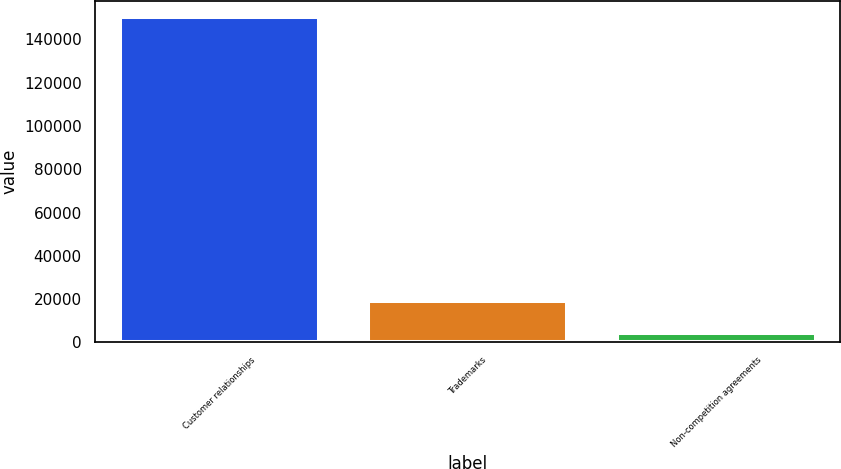<chart> <loc_0><loc_0><loc_500><loc_500><bar_chart><fcel>Customer relationships<fcel>Trademarks<fcel>Non-competition agreements<nl><fcel>150350<fcel>19054.4<fcel>4466<nl></chart> 